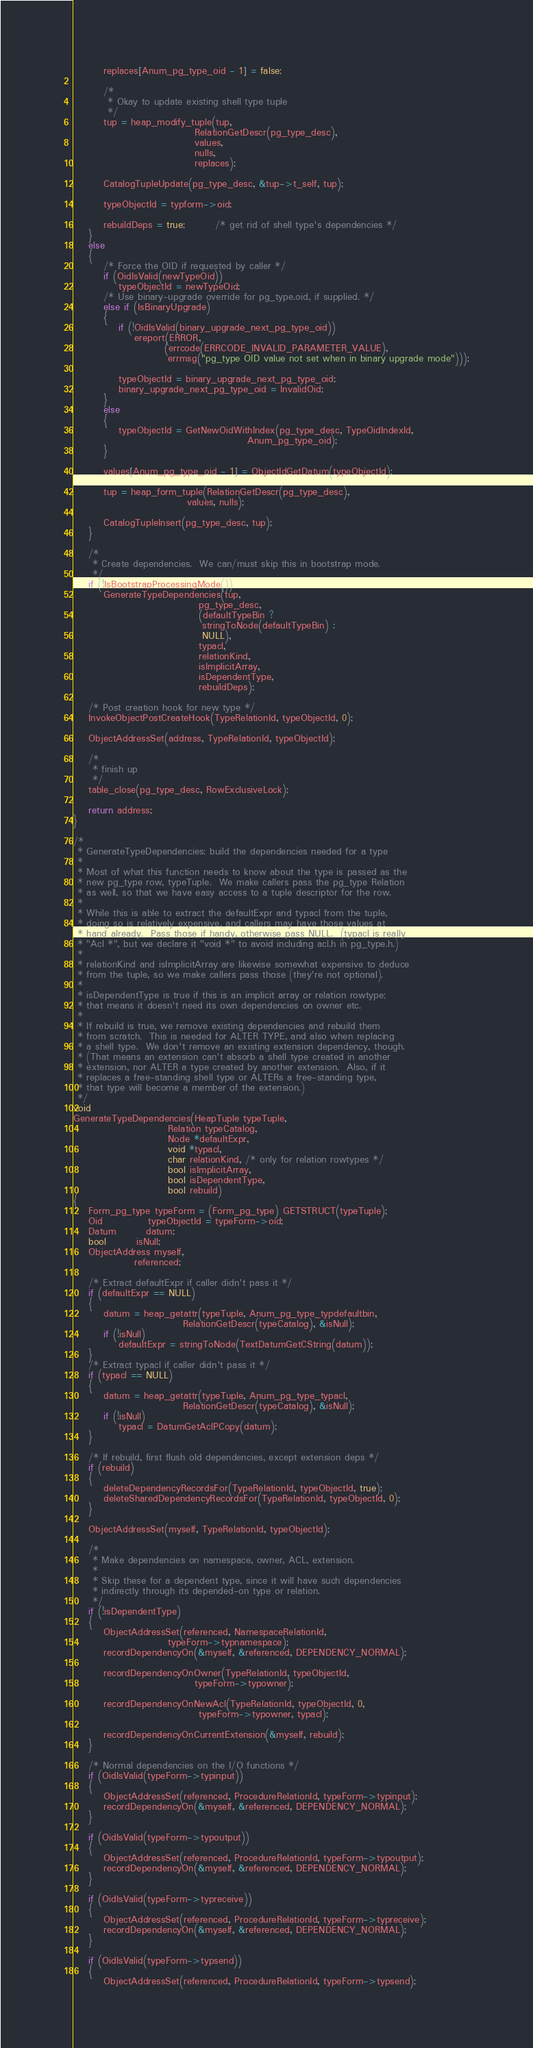Convert code to text. <code><loc_0><loc_0><loc_500><loc_500><_C_>		replaces[Anum_pg_type_oid - 1] = false;

		/*
		 * Okay to update existing shell type tuple
		 */
		tup = heap_modify_tuple(tup,
								RelationGetDescr(pg_type_desc),
								values,
								nulls,
								replaces);

		CatalogTupleUpdate(pg_type_desc, &tup->t_self, tup);

		typeObjectId = typform->oid;

		rebuildDeps = true;		/* get rid of shell type's dependencies */
	}
	else
	{
		/* Force the OID if requested by caller */
		if (OidIsValid(newTypeOid))
			typeObjectId = newTypeOid;
		/* Use binary-upgrade override for pg_type.oid, if supplied. */
		else if (IsBinaryUpgrade)
		{
			if (!OidIsValid(binary_upgrade_next_pg_type_oid))
				ereport(ERROR,
						(errcode(ERRCODE_INVALID_PARAMETER_VALUE),
						 errmsg("pg_type OID value not set when in binary upgrade mode")));

			typeObjectId = binary_upgrade_next_pg_type_oid;
			binary_upgrade_next_pg_type_oid = InvalidOid;
		}
		else
		{
			typeObjectId = GetNewOidWithIndex(pg_type_desc, TypeOidIndexId,
											  Anum_pg_type_oid);
		}

		values[Anum_pg_type_oid - 1] = ObjectIdGetDatum(typeObjectId);

		tup = heap_form_tuple(RelationGetDescr(pg_type_desc),
							  values, nulls);

		CatalogTupleInsert(pg_type_desc, tup);
	}

	/*
	 * Create dependencies.  We can/must skip this in bootstrap mode.
	 */
	if (!IsBootstrapProcessingMode())
		GenerateTypeDependencies(tup,
								 pg_type_desc,
								 (defaultTypeBin ?
								  stringToNode(defaultTypeBin) :
								  NULL),
								 typacl,
								 relationKind,
								 isImplicitArray,
								 isDependentType,
								 rebuildDeps);

	/* Post creation hook for new type */
	InvokeObjectPostCreateHook(TypeRelationId, typeObjectId, 0);

	ObjectAddressSet(address, TypeRelationId, typeObjectId);

	/*
	 * finish up
	 */
	table_close(pg_type_desc, RowExclusiveLock);

	return address;
}

/*
 * GenerateTypeDependencies: build the dependencies needed for a type
 *
 * Most of what this function needs to know about the type is passed as the
 * new pg_type row, typeTuple.  We make callers pass the pg_type Relation
 * as well, so that we have easy access to a tuple descriptor for the row.
 *
 * While this is able to extract the defaultExpr and typacl from the tuple,
 * doing so is relatively expensive, and callers may have those values at
 * hand already.  Pass those if handy, otherwise pass NULL.  (typacl is really
 * "Acl *", but we declare it "void *" to avoid including acl.h in pg_type.h.)
 *
 * relationKind and isImplicitArray are likewise somewhat expensive to deduce
 * from the tuple, so we make callers pass those (they're not optional).
 *
 * isDependentType is true if this is an implicit array or relation rowtype;
 * that means it doesn't need its own dependencies on owner etc.
 *
 * If rebuild is true, we remove existing dependencies and rebuild them
 * from scratch.  This is needed for ALTER TYPE, and also when replacing
 * a shell type.  We don't remove an existing extension dependency, though.
 * (That means an extension can't absorb a shell type created in another
 * extension, nor ALTER a type created by another extension.  Also, if it
 * replaces a free-standing shell type or ALTERs a free-standing type,
 * that type will become a member of the extension.)
 */
void
GenerateTypeDependencies(HeapTuple typeTuple,
						 Relation typeCatalog,
						 Node *defaultExpr,
						 void *typacl,
						 char relationKind, /* only for relation rowtypes */
						 bool isImplicitArray,
						 bool isDependentType,
						 bool rebuild)
{
	Form_pg_type typeForm = (Form_pg_type) GETSTRUCT(typeTuple);
	Oid			typeObjectId = typeForm->oid;
	Datum		datum;
	bool		isNull;
	ObjectAddress myself,
				referenced;

	/* Extract defaultExpr if caller didn't pass it */
	if (defaultExpr == NULL)
	{
		datum = heap_getattr(typeTuple, Anum_pg_type_typdefaultbin,
							 RelationGetDescr(typeCatalog), &isNull);
		if (!isNull)
			defaultExpr = stringToNode(TextDatumGetCString(datum));
	}
	/* Extract typacl if caller didn't pass it */
	if (typacl == NULL)
	{
		datum = heap_getattr(typeTuple, Anum_pg_type_typacl,
							 RelationGetDescr(typeCatalog), &isNull);
		if (!isNull)
			typacl = DatumGetAclPCopy(datum);
	}

	/* If rebuild, first flush old dependencies, except extension deps */
	if (rebuild)
	{
		deleteDependencyRecordsFor(TypeRelationId, typeObjectId, true);
		deleteSharedDependencyRecordsFor(TypeRelationId, typeObjectId, 0);
	}

	ObjectAddressSet(myself, TypeRelationId, typeObjectId);

	/*
	 * Make dependencies on namespace, owner, ACL, extension.
	 *
	 * Skip these for a dependent type, since it will have such dependencies
	 * indirectly through its depended-on type or relation.
	 */
	if (!isDependentType)
	{
		ObjectAddressSet(referenced, NamespaceRelationId,
						 typeForm->typnamespace);
		recordDependencyOn(&myself, &referenced, DEPENDENCY_NORMAL);

		recordDependencyOnOwner(TypeRelationId, typeObjectId,
								typeForm->typowner);

		recordDependencyOnNewAcl(TypeRelationId, typeObjectId, 0,
								 typeForm->typowner, typacl);

		recordDependencyOnCurrentExtension(&myself, rebuild);
	}

	/* Normal dependencies on the I/O functions */
	if (OidIsValid(typeForm->typinput))
	{
		ObjectAddressSet(referenced, ProcedureRelationId, typeForm->typinput);
		recordDependencyOn(&myself, &referenced, DEPENDENCY_NORMAL);
	}

	if (OidIsValid(typeForm->typoutput))
	{
		ObjectAddressSet(referenced, ProcedureRelationId, typeForm->typoutput);
		recordDependencyOn(&myself, &referenced, DEPENDENCY_NORMAL);
	}

	if (OidIsValid(typeForm->typreceive))
	{
		ObjectAddressSet(referenced, ProcedureRelationId, typeForm->typreceive);
		recordDependencyOn(&myself, &referenced, DEPENDENCY_NORMAL);
	}

	if (OidIsValid(typeForm->typsend))
	{
		ObjectAddressSet(referenced, ProcedureRelationId, typeForm->typsend);</code> 